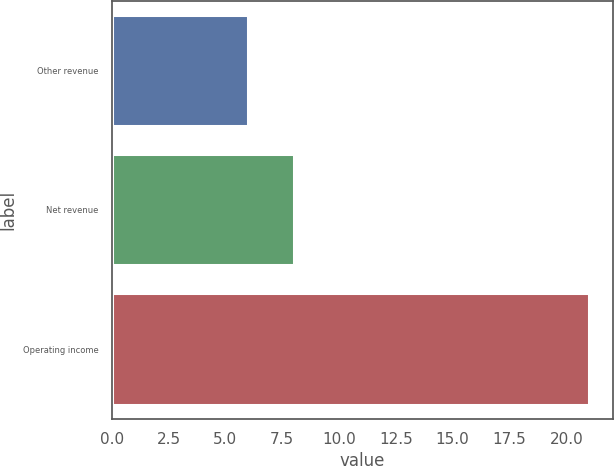<chart> <loc_0><loc_0><loc_500><loc_500><bar_chart><fcel>Other revenue<fcel>Net revenue<fcel>Operating income<nl><fcel>6<fcel>8<fcel>21<nl></chart> 